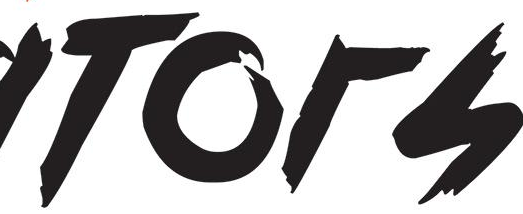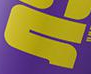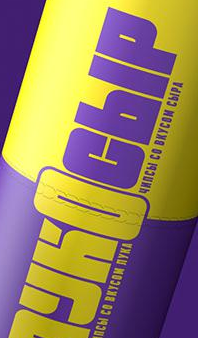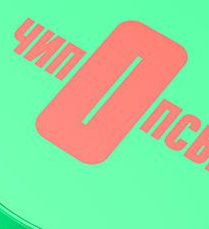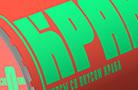Transcribe the words shown in these images in order, separated by a semicolon. TOrS; #; YKOCbIP; nOnC; KPA 